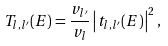Convert formula to latex. <formula><loc_0><loc_0><loc_500><loc_500>T _ { l , l ^ { \prime } } ( E ) = \frac { v _ { l ^ { \prime } } } { v _ { l } } \left | t _ { l , l ^ { \prime } } ( E ) \right | ^ { 2 } ,</formula> 